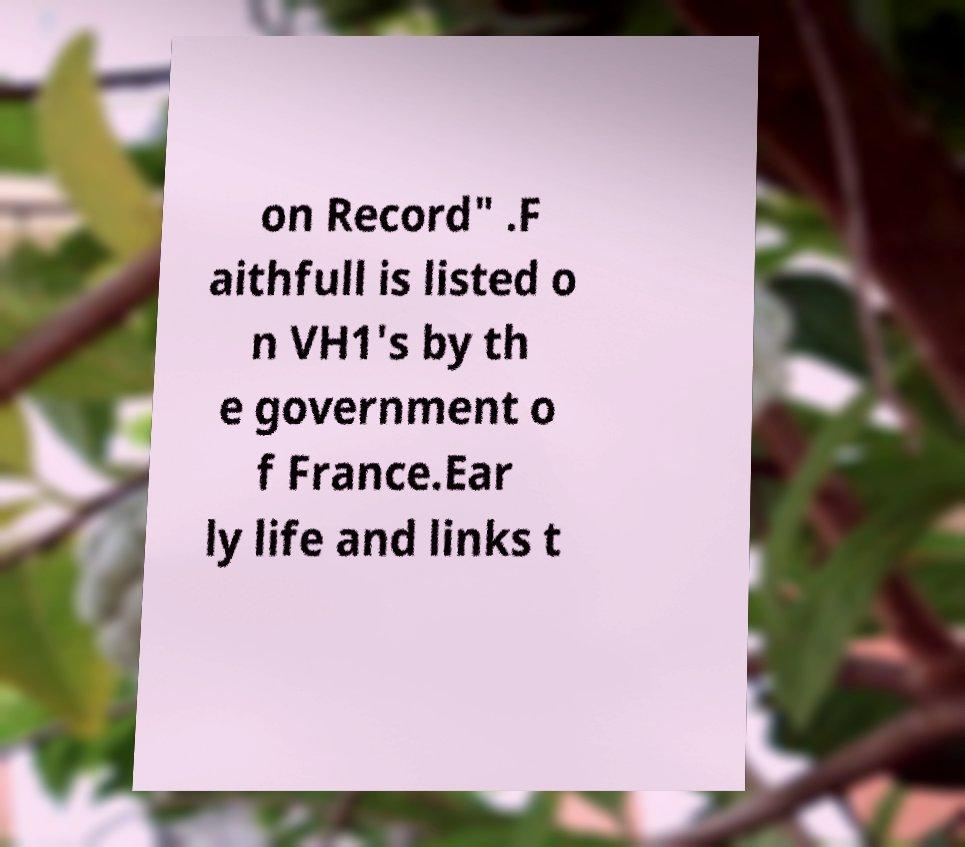Could you assist in decoding the text presented in this image and type it out clearly? on Record" .F aithfull is listed o n VH1's by th e government o f France.Ear ly life and links t 